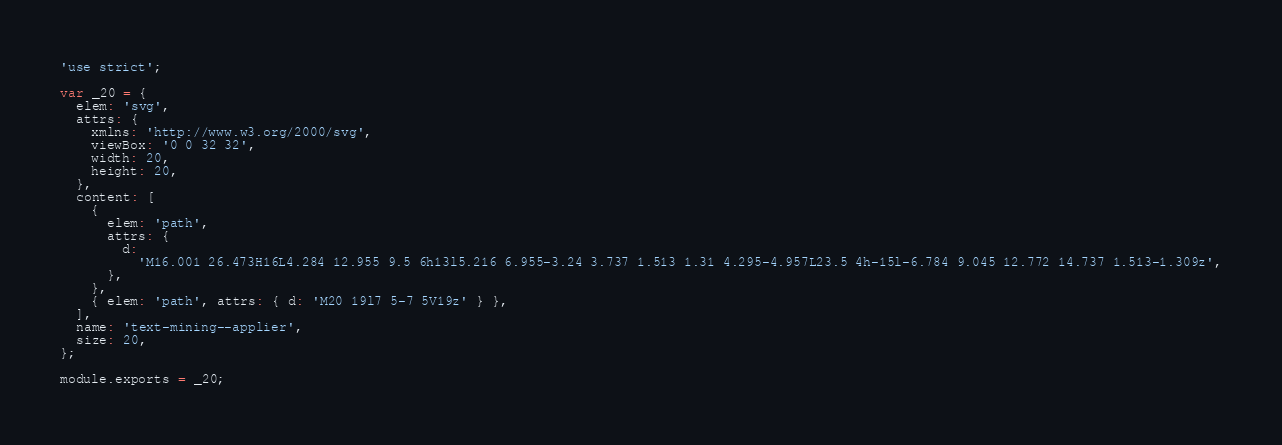Convert code to text. <code><loc_0><loc_0><loc_500><loc_500><_JavaScript_>'use strict';

var _20 = {
  elem: 'svg',
  attrs: {
    xmlns: 'http://www.w3.org/2000/svg',
    viewBox: '0 0 32 32',
    width: 20,
    height: 20,
  },
  content: [
    {
      elem: 'path',
      attrs: {
        d:
          'M16.001 26.473H16L4.284 12.955 9.5 6h13l5.216 6.955-3.24 3.737 1.513 1.31 4.295-4.957L23.5 4h-15l-6.784 9.045 12.772 14.737 1.513-1.309z',
      },
    },
    { elem: 'path', attrs: { d: 'M20 19l7 5-7 5V19z' } },
  ],
  name: 'text-mining--applier',
  size: 20,
};

module.exports = _20;
</code> 